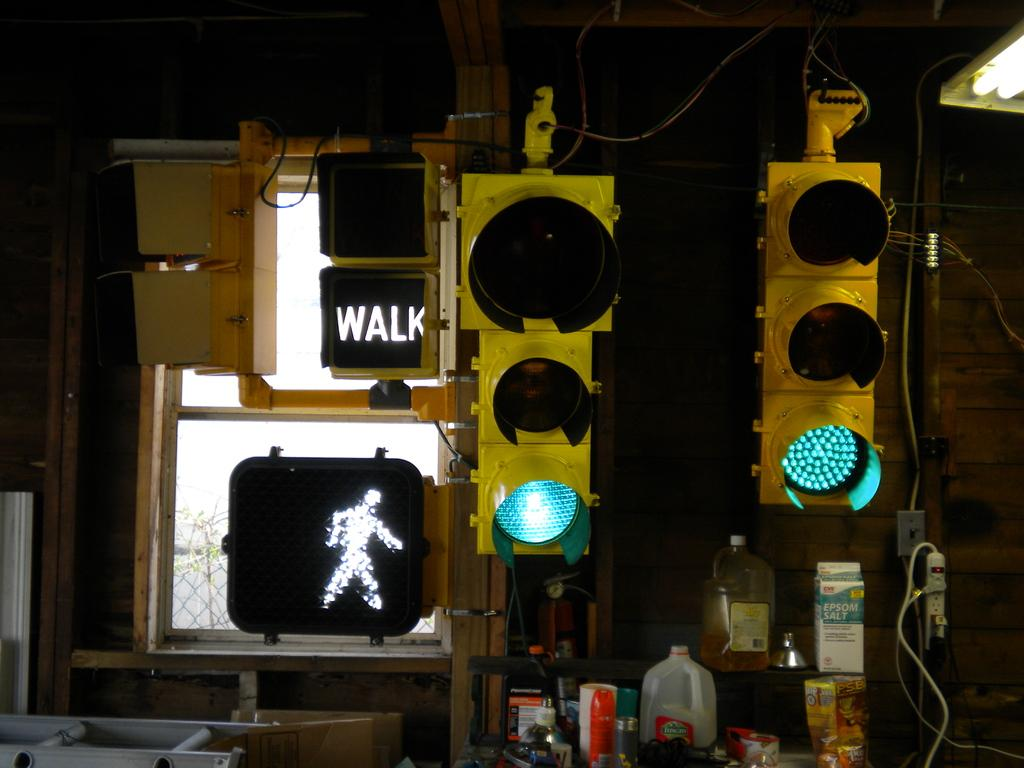<image>
Describe the image concisely. You are allowed to walk across according to the sign. 